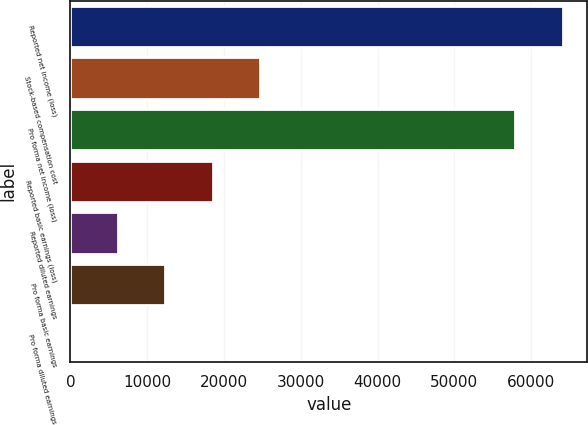Convert chart. <chart><loc_0><loc_0><loc_500><loc_500><bar_chart><fcel>Reported net income (loss)<fcel>Stock-based compensation cost<fcel>Pro forma net income (loss)<fcel>Reported basic earnings (loss)<fcel>Reported diluted earnings<fcel>Pro forma basic earnings<fcel>Pro forma diluted earnings<nl><fcel>64112.9<fcel>24676.3<fcel>57944<fcel>18507.4<fcel>6169.49<fcel>12338.4<fcel>0.54<nl></chart> 